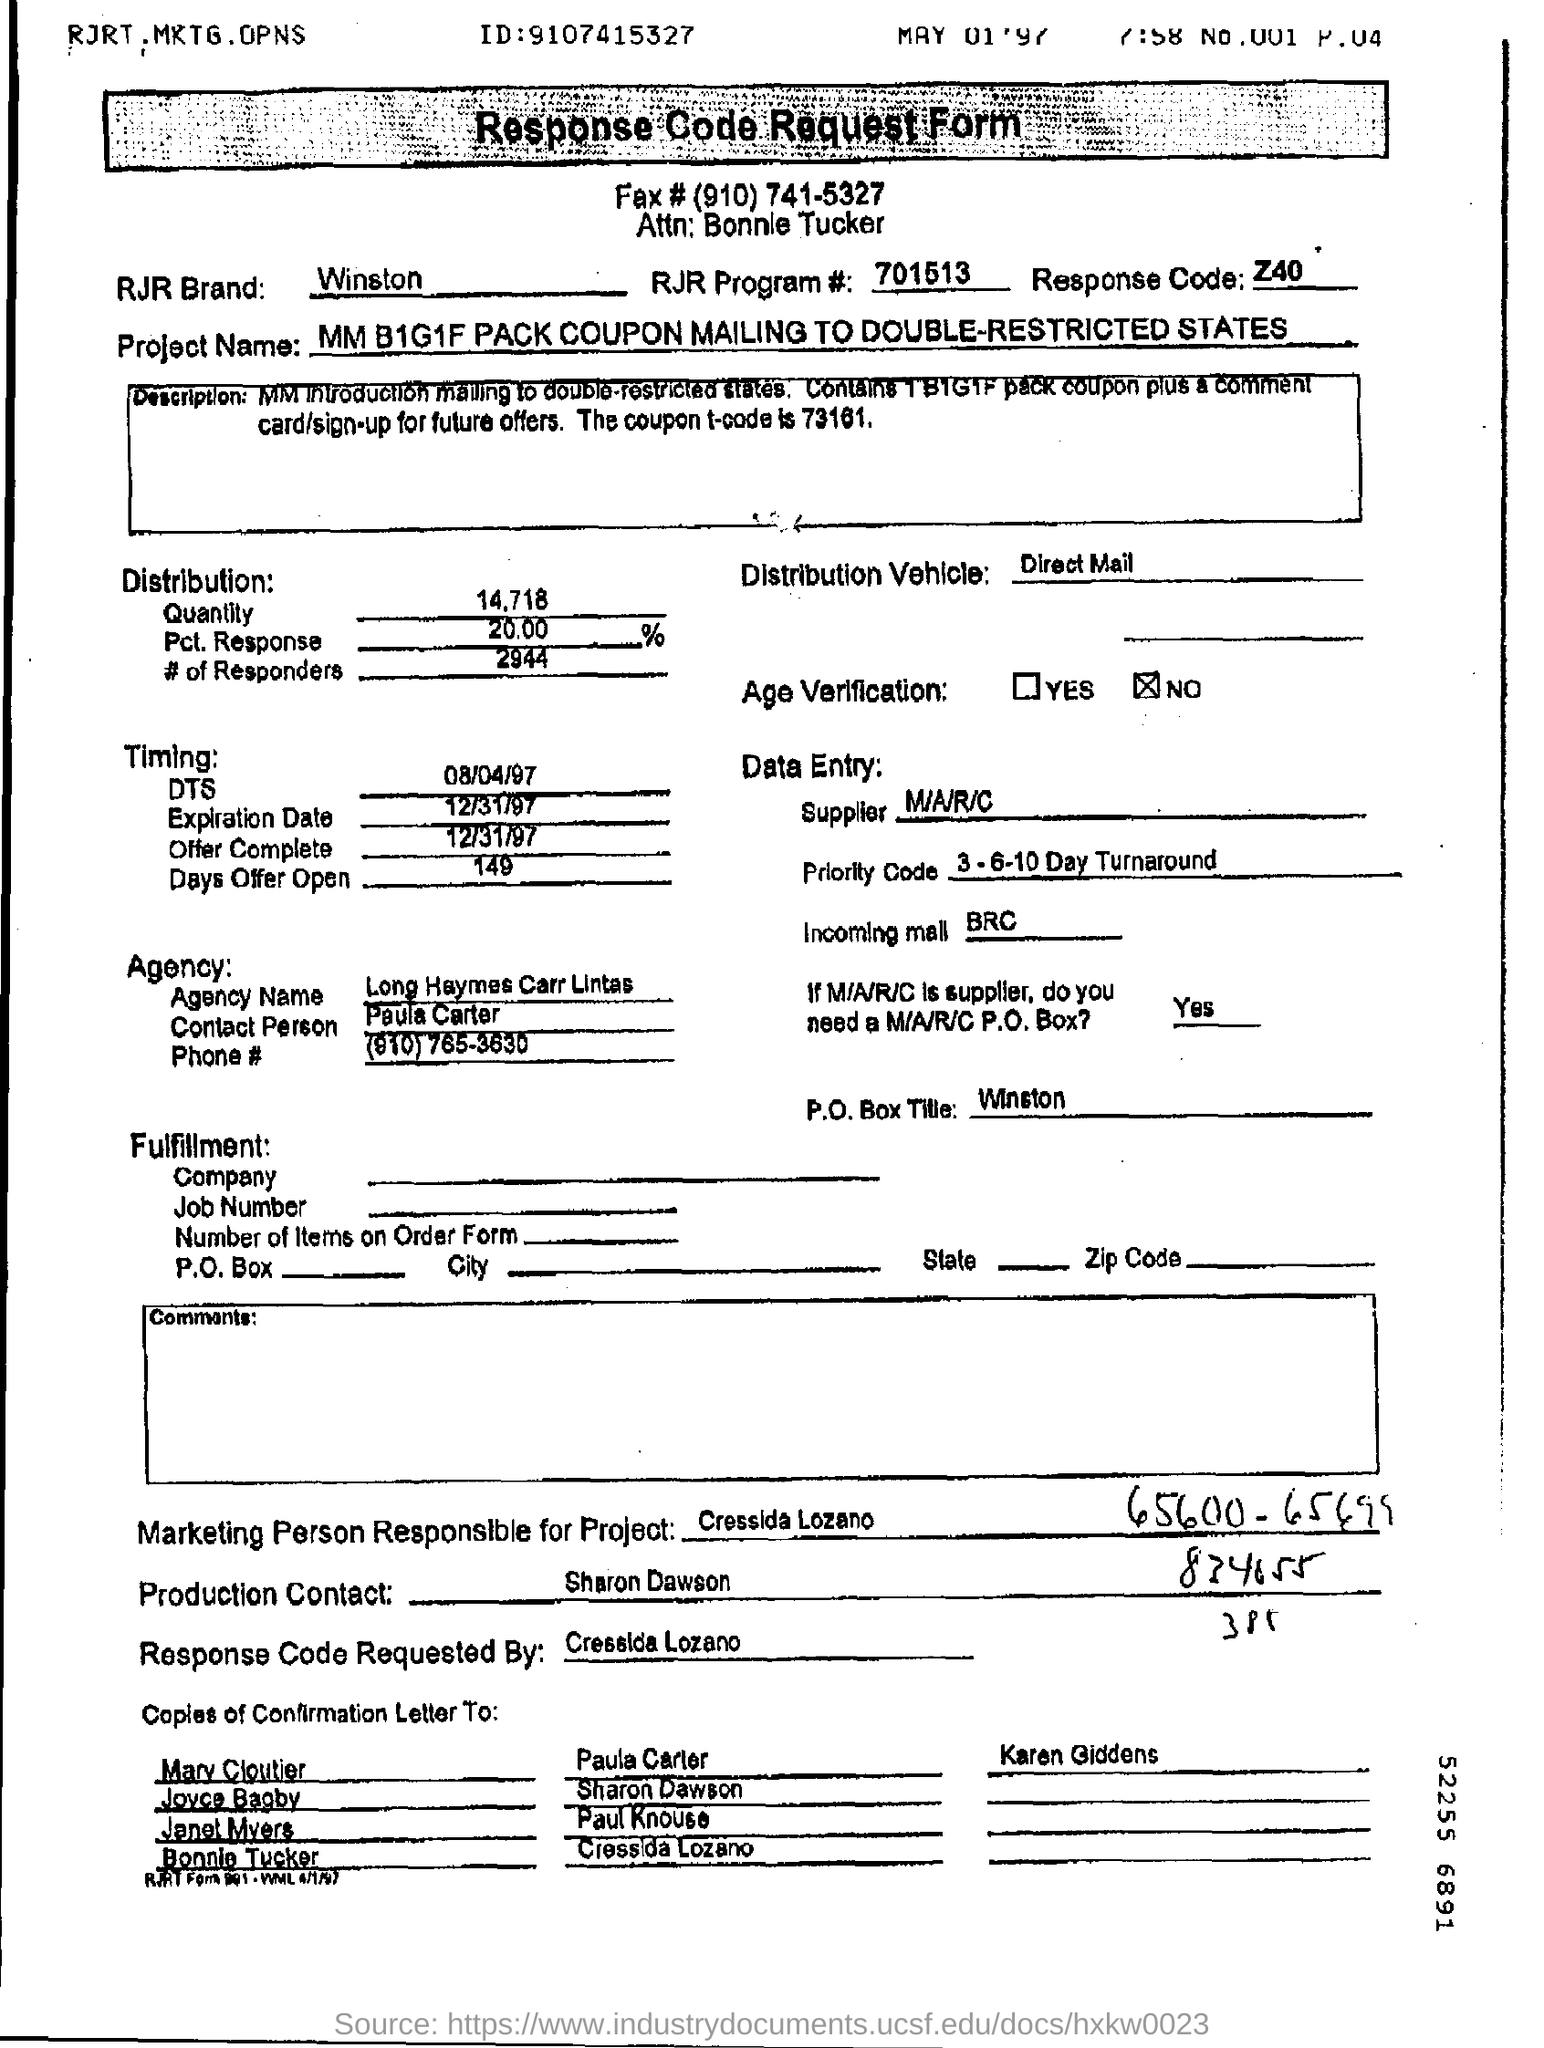What can you infer about the company's marketing strategy from this form? Based on the form, it seems the company was using direct mail as a distribution vehicle, targeting specific states with coupon offers to drive sales. The presence of age verification options on the form suggests they were marketing to an adult demographic, perhaps due to the nature of the product, which is likely tobacco, given the RJR Brand's historical association with cigarettes. 